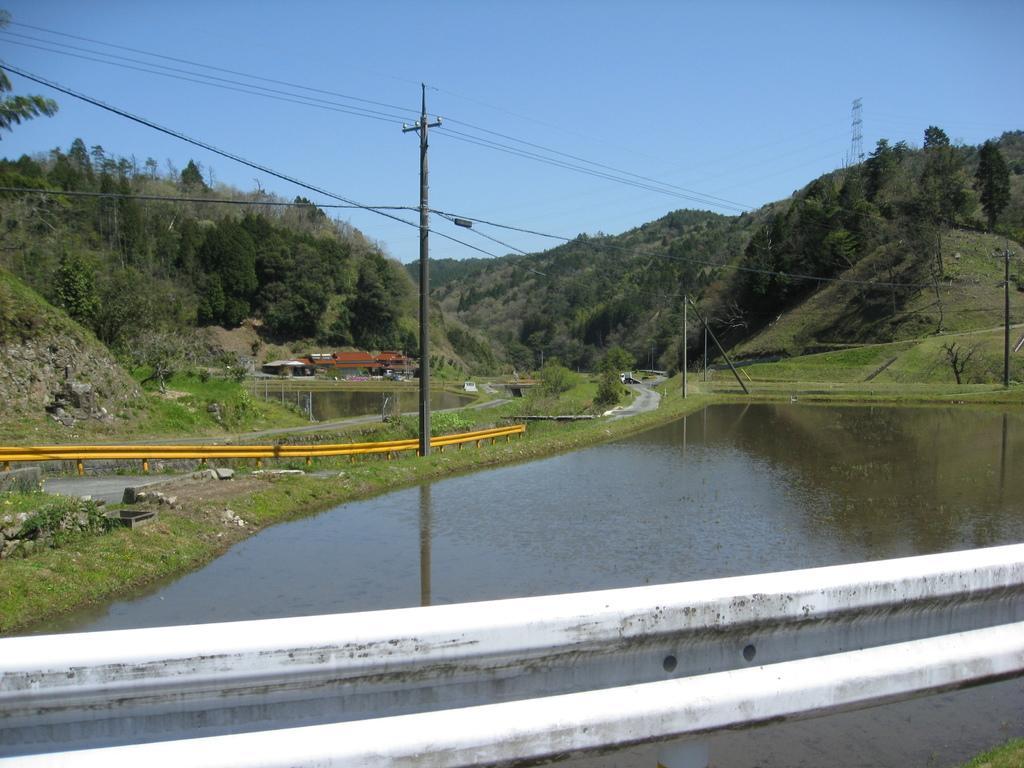Describe this image in one or two sentences. In this image there is a cane and fence visible at the bottom, in the middle there is a pole, power line cables, house, small canal, bridge, road, trees ,at the top there is the sky visible. 